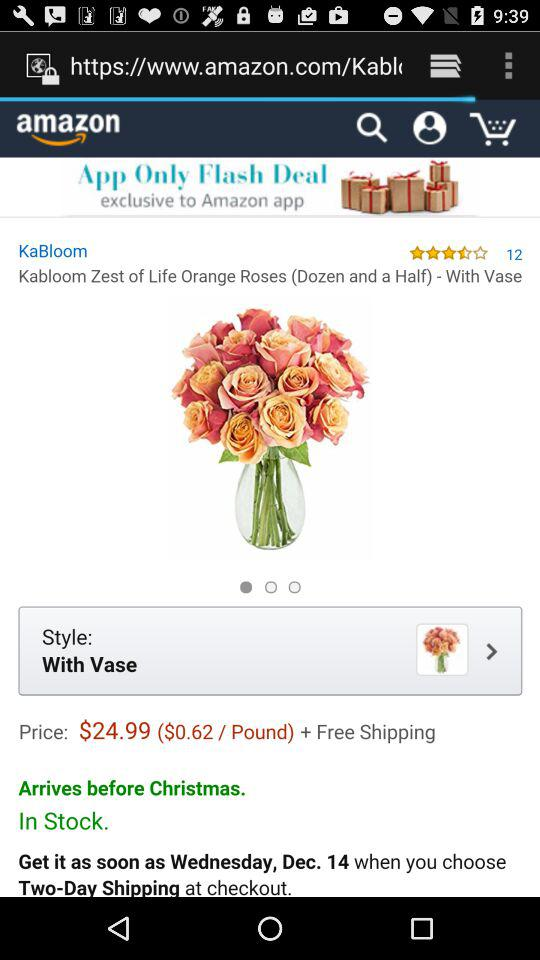What is the time duration of the shipment? The duration of the shipment is two days. 